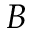<formula> <loc_0><loc_0><loc_500><loc_500>B</formula> 